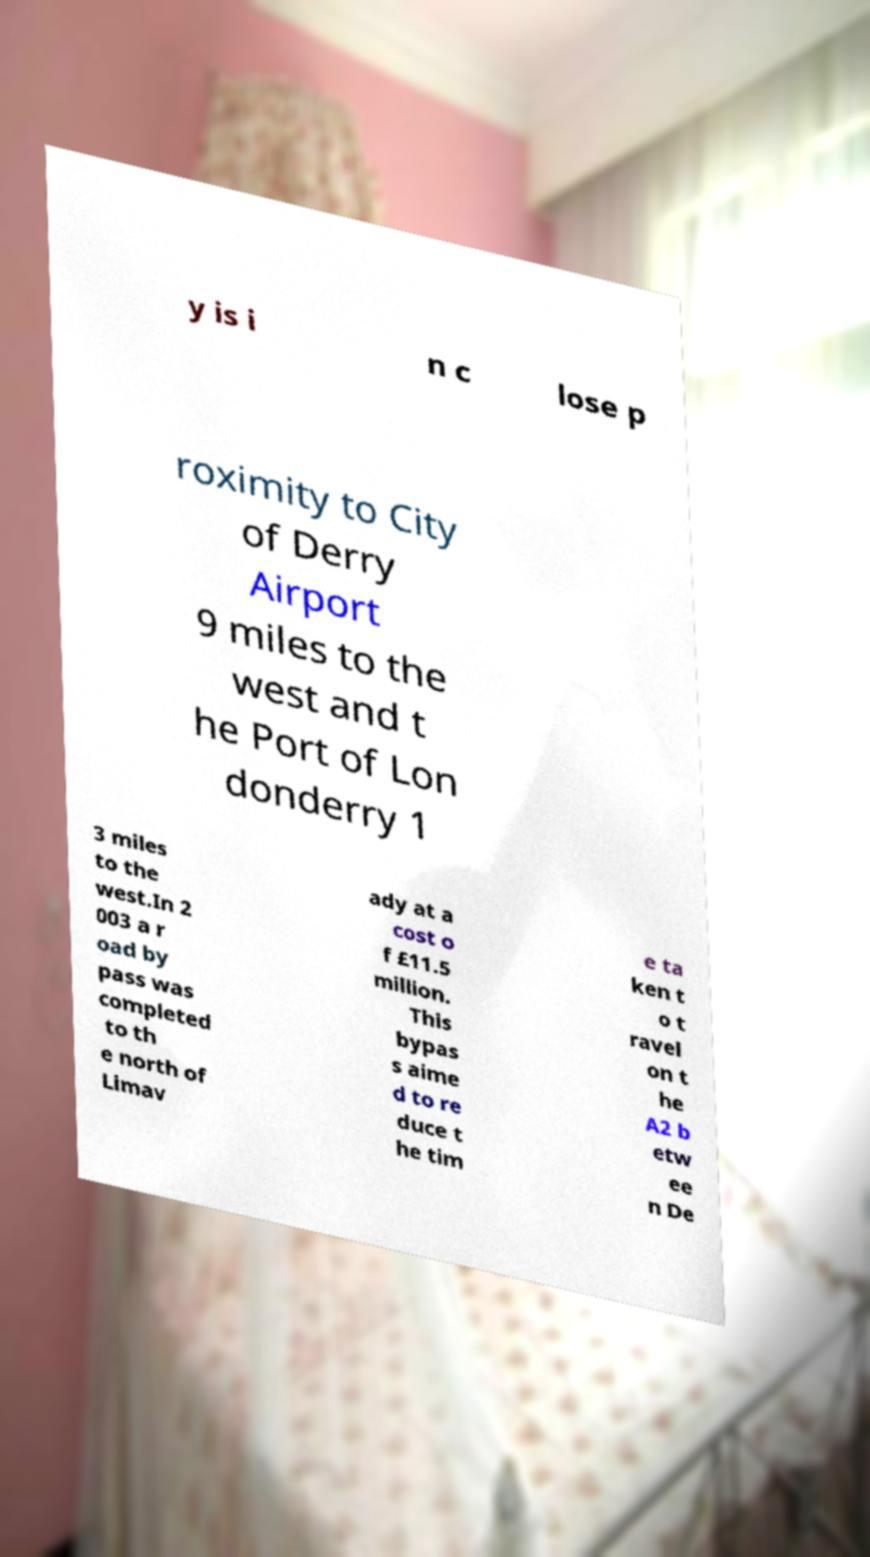Can you accurately transcribe the text from the provided image for me? y is i n c lose p roximity to City of Derry Airport 9 miles to the west and t he Port of Lon donderry 1 3 miles to the west.In 2 003 a r oad by pass was completed to th e north of Limav ady at a cost o f £11.5 million. This bypas s aime d to re duce t he tim e ta ken t o t ravel on t he A2 b etw ee n De 